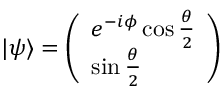Convert formula to latex. <formula><loc_0><loc_0><loc_500><loc_500>\begin{array} { r } { | \psi \rangle = \left ( \begin{array} { l } { e ^ { - i \phi } \cos \frac { \theta } { 2 } } \\ { \sin \frac { \theta } { 2 } } \end{array} \right ) } \end{array}</formula> 